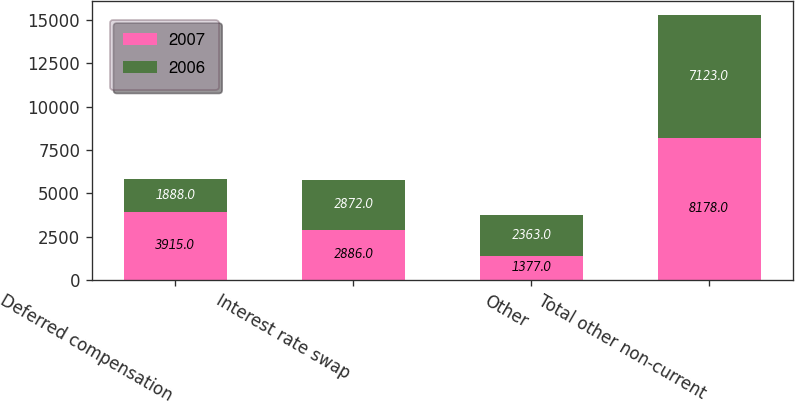<chart> <loc_0><loc_0><loc_500><loc_500><stacked_bar_chart><ecel><fcel>Deferred compensation<fcel>Interest rate swap<fcel>Other<fcel>Total other non-current<nl><fcel>2007<fcel>3915<fcel>2886<fcel>1377<fcel>8178<nl><fcel>2006<fcel>1888<fcel>2872<fcel>2363<fcel>7123<nl></chart> 